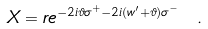<formula> <loc_0><loc_0><loc_500><loc_500>X = r e ^ { - 2 i \vartheta \sigma ^ { + } - 2 i ( w ^ { \prime } + \vartheta ) \sigma ^ { - } } \ .</formula> 